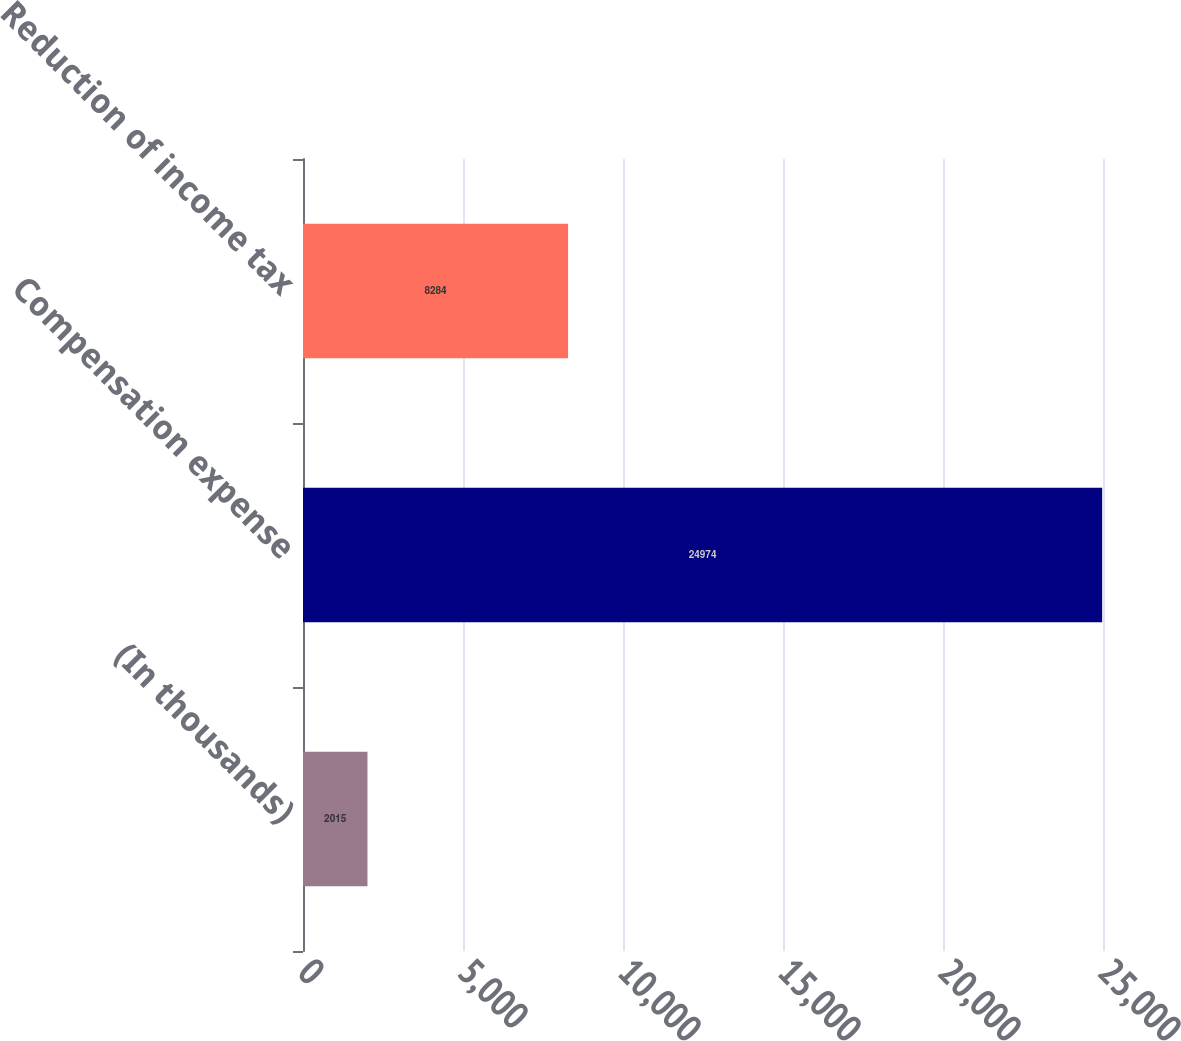<chart> <loc_0><loc_0><loc_500><loc_500><bar_chart><fcel>(In thousands)<fcel>Compensation expense<fcel>Reduction of income tax<nl><fcel>2015<fcel>24974<fcel>8284<nl></chart> 